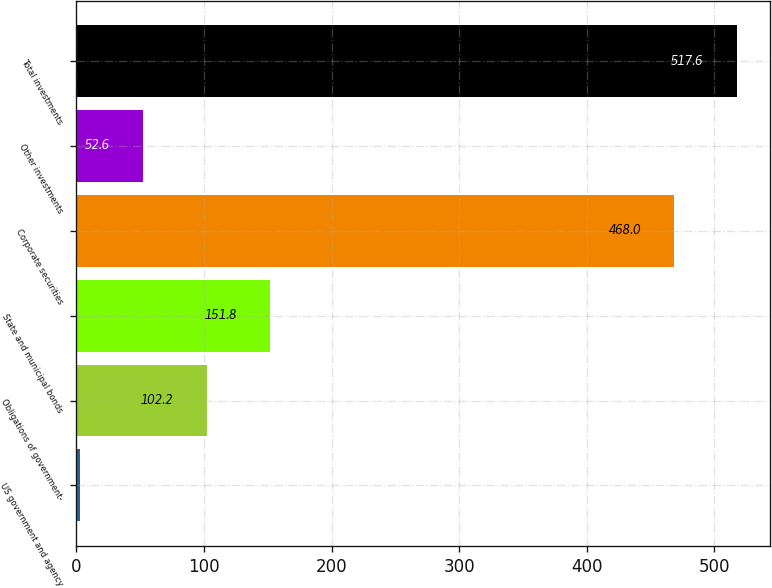Convert chart to OTSL. <chart><loc_0><loc_0><loc_500><loc_500><bar_chart><fcel>US government and agency<fcel>Obligations of government-<fcel>State and municipal bonds<fcel>Corporate securities<fcel>Other investments<fcel>Total investments<nl><fcel>3<fcel>102.2<fcel>151.8<fcel>468<fcel>52.6<fcel>517.6<nl></chart> 